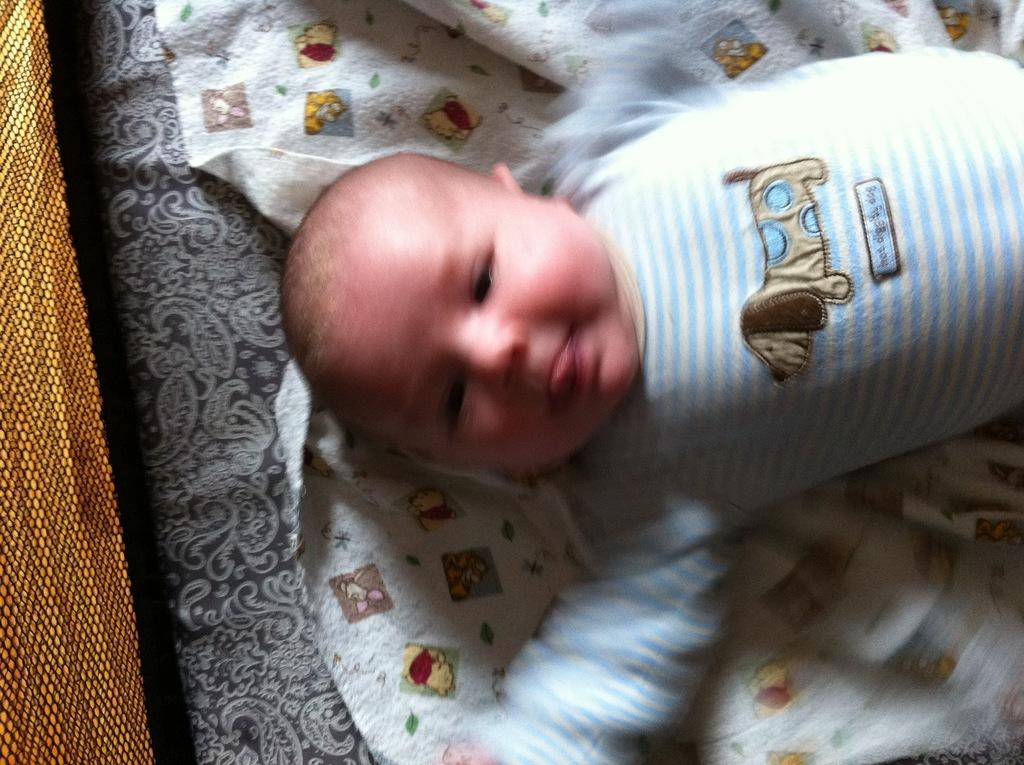What is the main subject of the image? The main subject of the image is a kid. What is the kid doing in the image? The kid is laying on a bed. Can you describe the object on the left side of the image? The object is golden in color. Who is the owner of the golden object in the image? There is no information about the ownership of the golden object in the image. How many wheels does the golden object have? The golden object in the image does not appear to be a wheeled object, so it cannot be determined how many wheels it has. 